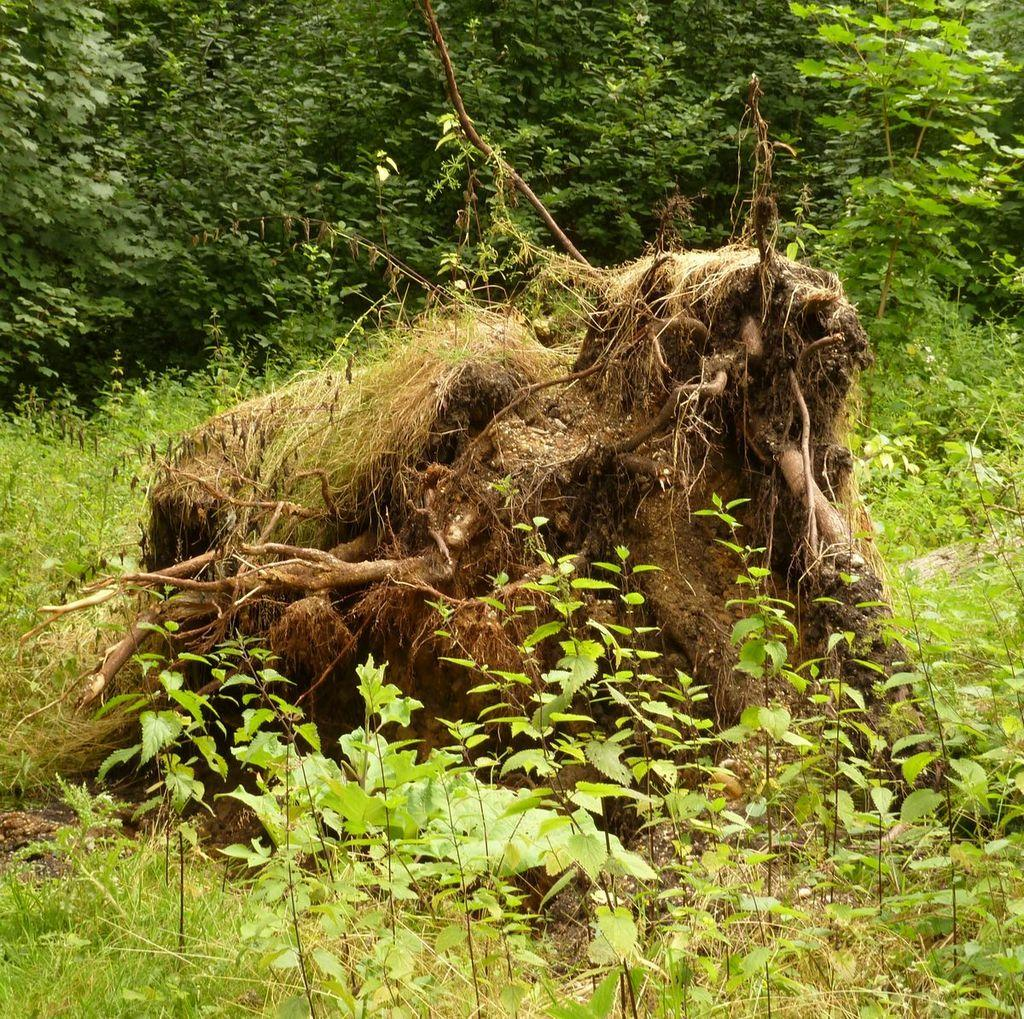What type of plant can be seen in the image? The image contains the roots of a tree and other plants. What type of vegetation is visible in the image? There is grass and a few trees visible in the image. How many types of plants can be seen in the image? There are at least three types of plants visible: the roots of a tree, grass, and other plants. What type of food is being prepared in the image? There is no food preparation visible in the image; it primarily features plants and vegetation. Can you see any bears in the image? There are no bears present in the image. 